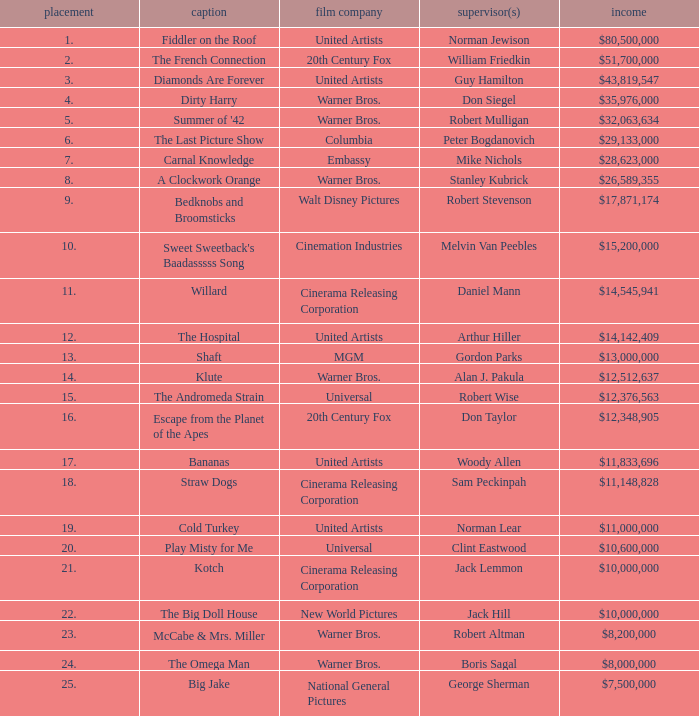Could you help me parse every detail presented in this table? {'header': ['placement', 'caption', 'film company', 'supervisor(s)', 'income'], 'rows': [['1.', 'Fiddler on the Roof', 'United Artists', 'Norman Jewison', '$80,500,000'], ['2.', 'The French Connection', '20th Century Fox', 'William Friedkin', '$51,700,000'], ['3.', 'Diamonds Are Forever', 'United Artists', 'Guy Hamilton', '$43,819,547'], ['4.', 'Dirty Harry', 'Warner Bros.', 'Don Siegel', '$35,976,000'], ['5.', "Summer of '42", 'Warner Bros.', 'Robert Mulligan', '$32,063,634'], ['6.', 'The Last Picture Show', 'Columbia', 'Peter Bogdanovich', '$29,133,000'], ['7.', 'Carnal Knowledge', 'Embassy', 'Mike Nichols', '$28,623,000'], ['8.', 'A Clockwork Orange', 'Warner Bros.', 'Stanley Kubrick', '$26,589,355'], ['9.', 'Bedknobs and Broomsticks', 'Walt Disney Pictures', 'Robert Stevenson', '$17,871,174'], ['10.', "Sweet Sweetback's Baadasssss Song", 'Cinemation Industries', 'Melvin Van Peebles', '$15,200,000'], ['11.', 'Willard', 'Cinerama Releasing Corporation', 'Daniel Mann', '$14,545,941'], ['12.', 'The Hospital', 'United Artists', 'Arthur Hiller', '$14,142,409'], ['13.', 'Shaft', 'MGM', 'Gordon Parks', '$13,000,000'], ['14.', 'Klute', 'Warner Bros.', 'Alan J. Pakula', '$12,512,637'], ['15.', 'The Andromeda Strain', 'Universal', 'Robert Wise', '$12,376,563'], ['16.', 'Escape from the Planet of the Apes', '20th Century Fox', 'Don Taylor', '$12,348,905'], ['17.', 'Bananas', 'United Artists', 'Woody Allen', '$11,833,696'], ['18.', 'Straw Dogs', 'Cinerama Releasing Corporation', 'Sam Peckinpah', '$11,148,828'], ['19.', 'Cold Turkey', 'United Artists', 'Norman Lear', '$11,000,000'], ['20.', 'Play Misty for Me', 'Universal', 'Clint Eastwood', '$10,600,000'], ['21.', 'Kotch', 'Cinerama Releasing Corporation', 'Jack Lemmon', '$10,000,000'], ['22.', 'The Big Doll House', 'New World Pictures', 'Jack Hill', '$10,000,000'], ['23.', 'McCabe & Mrs. Miller', 'Warner Bros.', 'Robert Altman', '$8,200,000'], ['24.', 'The Omega Man', 'Warner Bros.', 'Boris Sagal', '$8,000,000'], ['25.', 'Big Jake', 'National General Pictures', 'George Sherman', '$7,500,000']]} What rank has a gross of $35,976,000? 4.0. 